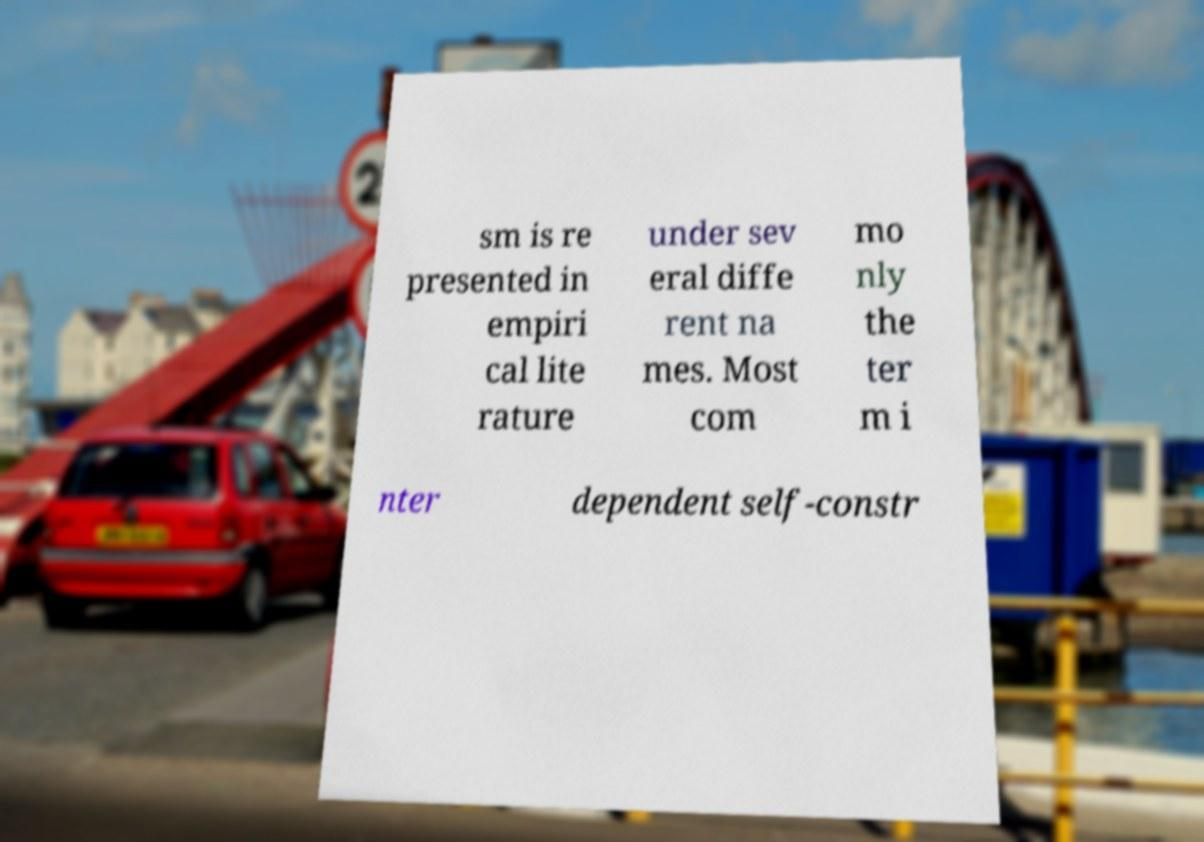There's text embedded in this image that I need extracted. Can you transcribe it verbatim? sm is re presented in empiri cal lite rature under sev eral diffe rent na mes. Most com mo nly the ter m i nter dependent self-constr 